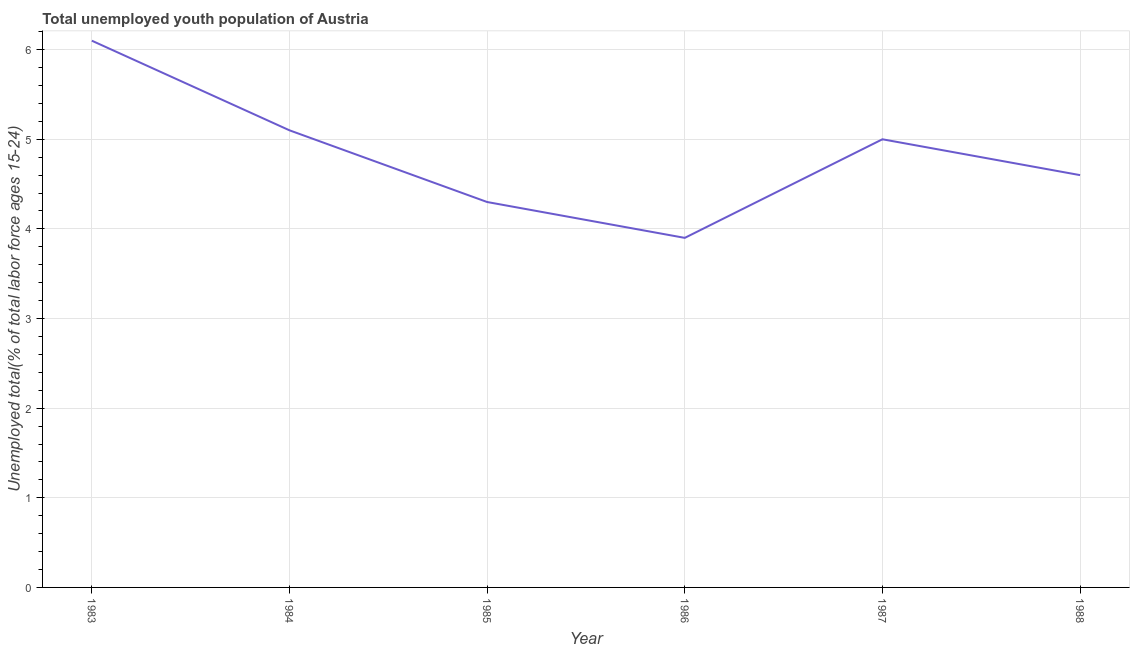What is the unemployed youth in 1988?
Keep it short and to the point. 4.6. Across all years, what is the maximum unemployed youth?
Your response must be concise. 6.1. Across all years, what is the minimum unemployed youth?
Make the answer very short. 3.9. In which year was the unemployed youth maximum?
Provide a short and direct response. 1983. What is the sum of the unemployed youth?
Provide a succinct answer. 29. What is the difference between the unemployed youth in 1985 and 1986?
Give a very brief answer. 0.4. What is the average unemployed youth per year?
Give a very brief answer. 4.83. What is the median unemployed youth?
Keep it short and to the point. 4.8. Do a majority of the years between 1985 and 1984 (inclusive) have unemployed youth greater than 3 %?
Your response must be concise. No. What is the ratio of the unemployed youth in 1985 to that in 1986?
Your answer should be compact. 1.1. Is the difference between the unemployed youth in 1983 and 1985 greater than the difference between any two years?
Your answer should be compact. No. What is the difference between the highest and the second highest unemployed youth?
Keep it short and to the point. 1. What is the difference between the highest and the lowest unemployed youth?
Provide a succinct answer. 2.2. Does the unemployed youth monotonically increase over the years?
Make the answer very short. No. How many lines are there?
Your answer should be compact. 1. How many years are there in the graph?
Give a very brief answer. 6. Are the values on the major ticks of Y-axis written in scientific E-notation?
Make the answer very short. No. Does the graph contain grids?
Offer a terse response. Yes. What is the title of the graph?
Your response must be concise. Total unemployed youth population of Austria. What is the label or title of the Y-axis?
Offer a very short reply. Unemployed total(% of total labor force ages 15-24). What is the Unemployed total(% of total labor force ages 15-24) of 1983?
Give a very brief answer. 6.1. What is the Unemployed total(% of total labor force ages 15-24) in 1984?
Make the answer very short. 5.1. What is the Unemployed total(% of total labor force ages 15-24) of 1985?
Offer a very short reply. 4.3. What is the Unemployed total(% of total labor force ages 15-24) in 1986?
Ensure brevity in your answer.  3.9. What is the Unemployed total(% of total labor force ages 15-24) in 1988?
Ensure brevity in your answer.  4.6. What is the difference between the Unemployed total(% of total labor force ages 15-24) in 1983 and 1985?
Offer a very short reply. 1.8. What is the difference between the Unemployed total(% of total labor force ages 15-24) in 1984 and 1986?
Offer a very short reply. 1.2. What is the difference between the Unemployed total(% of total labor force ages 15-24) in 1984 and 1988?
Offer a very short reply. 0.5. What is the difference between the Unemployed total(% of total labor force ages 15-24) in 1985 and 1986?
Provide a succinct answer. 0.4. What is the difference between the Unemployed total(% of total labor force ages 15-24) in 1985 and 1987?
Provide a succinct answer. -0.7. What is the difference between the Unemployed total(% of total labor force ages 15-24) in 1985 and 1988?
Provide a succinct answer. -0.3. What is the difference between the Unemployed total(% of total labor force ages 15-24) in 1986 and 1987?
Ensure brevity in your answer.  -1.1. What is the difference between the Unemployed total(% of total labor force ages 15-24) in 1987 and 1988?
Keep it short and to the point. 0.4. What is the ratio of the Unemployed total(% of total labor force ages 15-24) in 1983 to that in 1984?
Keep it short and to the point. 1.2. What is the ratio of the Unemployed total(% of total labor force ages 15-24) in 1983 to that in 1985?
Your answer should be very brief. 1.42. What is the ratio of the Unemployed total(% of total labor force ages 15-24) in 1983 to that in 1986?
Give a very brief answer. 1.56. What is the ratio of the Unemployed total(% of total labor force ages 15-24) in 1983 to that in 1987?
Your answer should be very brief. 1.22. What is the ratio of the Unemployed total(% of total labor force ages 15-24) in 1983 to that in 1988?
Provide a short and direct response. 1.33. What is the ratio of the Unemployed total(% of total labor force ages 15-24) in 1984 to that in 1985?
Your answer should be very brief. 1.19. What is the ratio of the Unemployed total(% of total labor force ages 15-24) in 1984 to that in 1986?
Provide a succinct answer. 1.31. What is the ratio of the Unemployed total(% of total labor force ages 15-24) in 1984 to that in 1988?
Your response must be concise. 1.11. What is the ratio of the Unemployed total(% of total labor force ages 15-24) in 1985 to that in 1986?
Give a very brief answer. 1.1. What is the ratio of the Unemployed total(% of total labor force ages 15-24) in 1985 to that in 1987?
Provide a succinct answer. 0.86. What is the ratio of the Unemployed total(% of total labor force ages 15-24) in 1985 to that in 1988?
Make the answer very short. 0.94. What is the ratio of the Unemployed total(% of total labor force ages 15-24) in 1986 to that in 1987?
Your response must be concise. 0.78. What is the ratio of the Unemployed total(% of total labor force ages 15-24) in 1986 to that in 1988?
Your response must be concise. 0.85. What is the ratio of the Unemployed total(% of total labor force ages 15-24) in 1987 to that in 1988?
Make the answer very short. 1.09. 